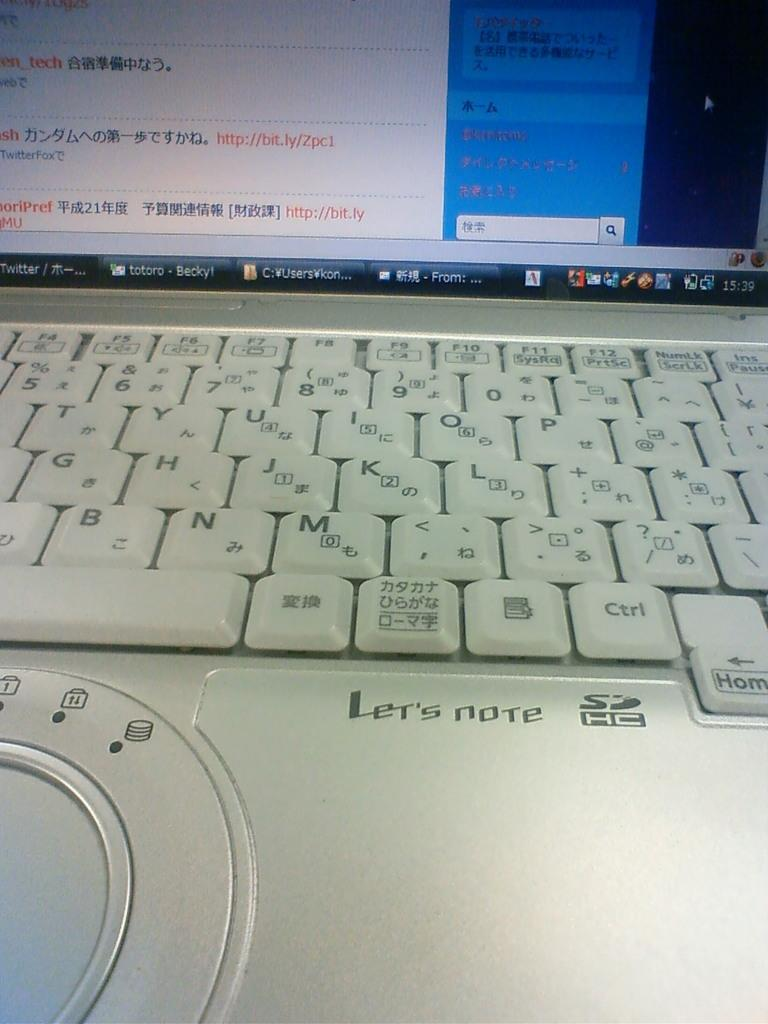<image>
Present a compact description of the photo's key features. A silver computer which shows Chinese lettering and other applications 